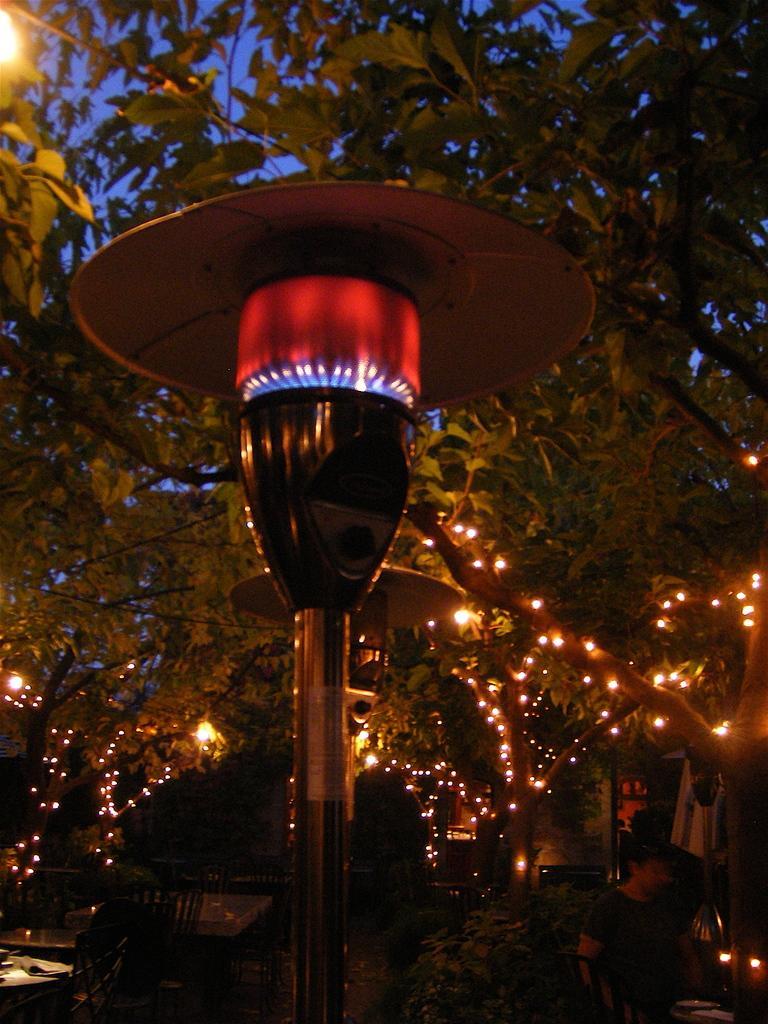In one or two sentences, can you explain what this image depicts? In this picture we can see a building and few lights on a tree. There is a person visible on the right side. We can see few chairs and tables on the left side. We can see an object. 